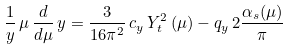<formula> <loc_0><loc_0><loc_500><loc_500>\frac { 1 } { y } \, \mu \, \frac { d } { d \mu } \, y = \frac { 3 } { 1 6 \pi ^ { 2 } } \, c _ { y } \, Y _ { t } ^ { 2 } \left ( \mu \right ) - q _ { y } \, 2 \frac { \alpha _ { s } ( \mu ) } { \pi }</formula> 